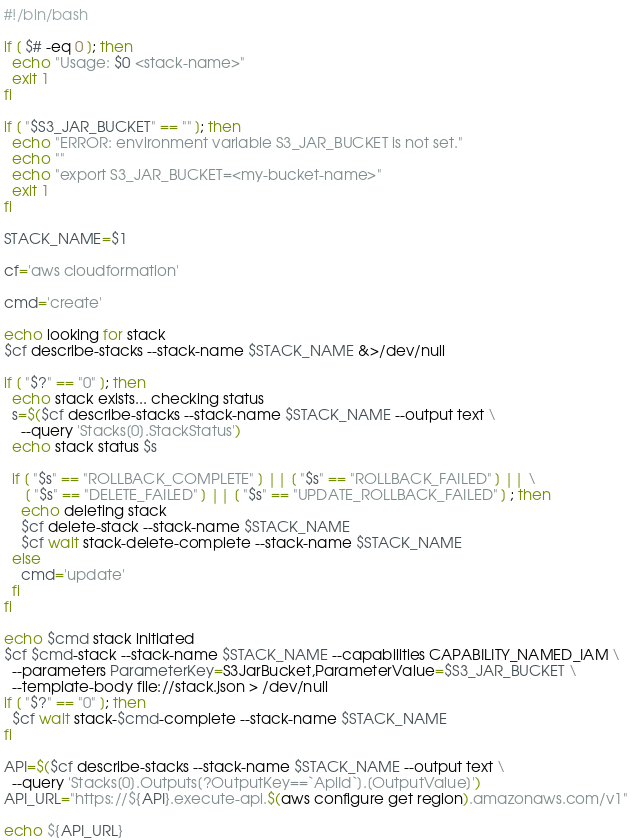<code> <loc_0><loc_0><loc_500><loc_500><_Bash_>#!/bin/bash

if [ $# -eq 0 ]; then
  echo "Usage: $0 <stack-name>"
  exit 1
fi

if [ "$S3_JAR_BUCKET" == "" ]; then
  echo "ERROR: environment variable S3_JAR_BUCKET is not set."
  echo ""
  echo "export S3_JAR_BUCKET=<my-bucket-name>"
  exit 1
fi

STACK_NAME=$1

cf='aws cloudformation'

cmd='create'

echo looking for stack
$cf describe-stacks --stack-name $STACK_NAME &>/dev/null

if [ "$?" == "0" ]; then
  echo stack exists... checking status
  s=$($cf describe-stacks --stack-name $STACK_NAME --output text \
    --query 'Stacks[0].StackStatus')
  echo stack status $s

  if [ "$s" == "ROLLBACK_COMPLETE" ] || [ "$s" == "ROLLBACK_FAILED" ] || \
     [ "$s" == "DELETE_FAILED" ] || [ "$s" == "UPDATE_ROLLBACK_FAILED" ] ; then
    echo deleting stack
    $cf delete-stack --stack-name $STACK_NAME
    $cf wait stack-delete-complete --stack-name $STACK_NAME
  else
    cmd='update'
  fi
fi

echo $cmd stack initiated
$cf $cmd-stack --stack-name $STACK_NAME --capabilities CAPABILITY_NAMED_IAM \
  --parameters ParameterKey=S3JarBucket,ParameterValue=$S3_JAR_BUCKET \
  --template-body file://stack.json > /dev/null
if [ "$?" == "0" ]; then
  $cf wait stack-$cmd-complete --stack-name $STACK_NAME
fi

API=$($cf describe-stacks --stack-name $STACK_NAME --output text \
  --query 'Stacks[0].Outputs[?OutputKey==`ApiId`].[OutputValue]')
API_URL="https://${API}.execute-api.$(aws configure get region).amazonaws.com/v1"

echo ${API_URL}</code> 